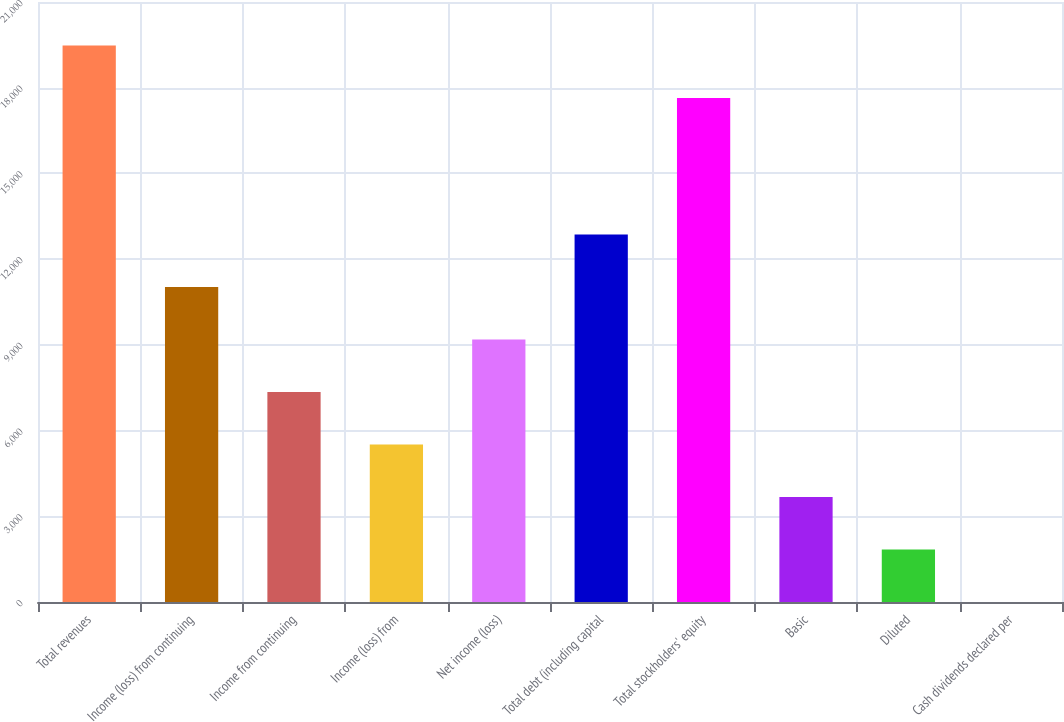Convert chart to OTSL. <chart><loc_0><loc_0><loc_500><loc_500><bar_chart><fcel>Total revenues<fcel>Income (loss) from continuing<fcel>Income from continuing<fcel>Income (loss) from<fcel>Net income (loss)<fcel>Total debt (including capital<fcel>Total stockholders' equity<fcel>Basic<fcel>Diluted<fcel>Cash dividends declared per<nl><fcel>19479.6<fcel>11026.5<fcel>7351.26<fcel>5513.64<fcel>9188.88<fcel>12864.1<fcel>17642<fcel>3676.02<fcel>1838.4<fcel>0.78<nl></chart> 